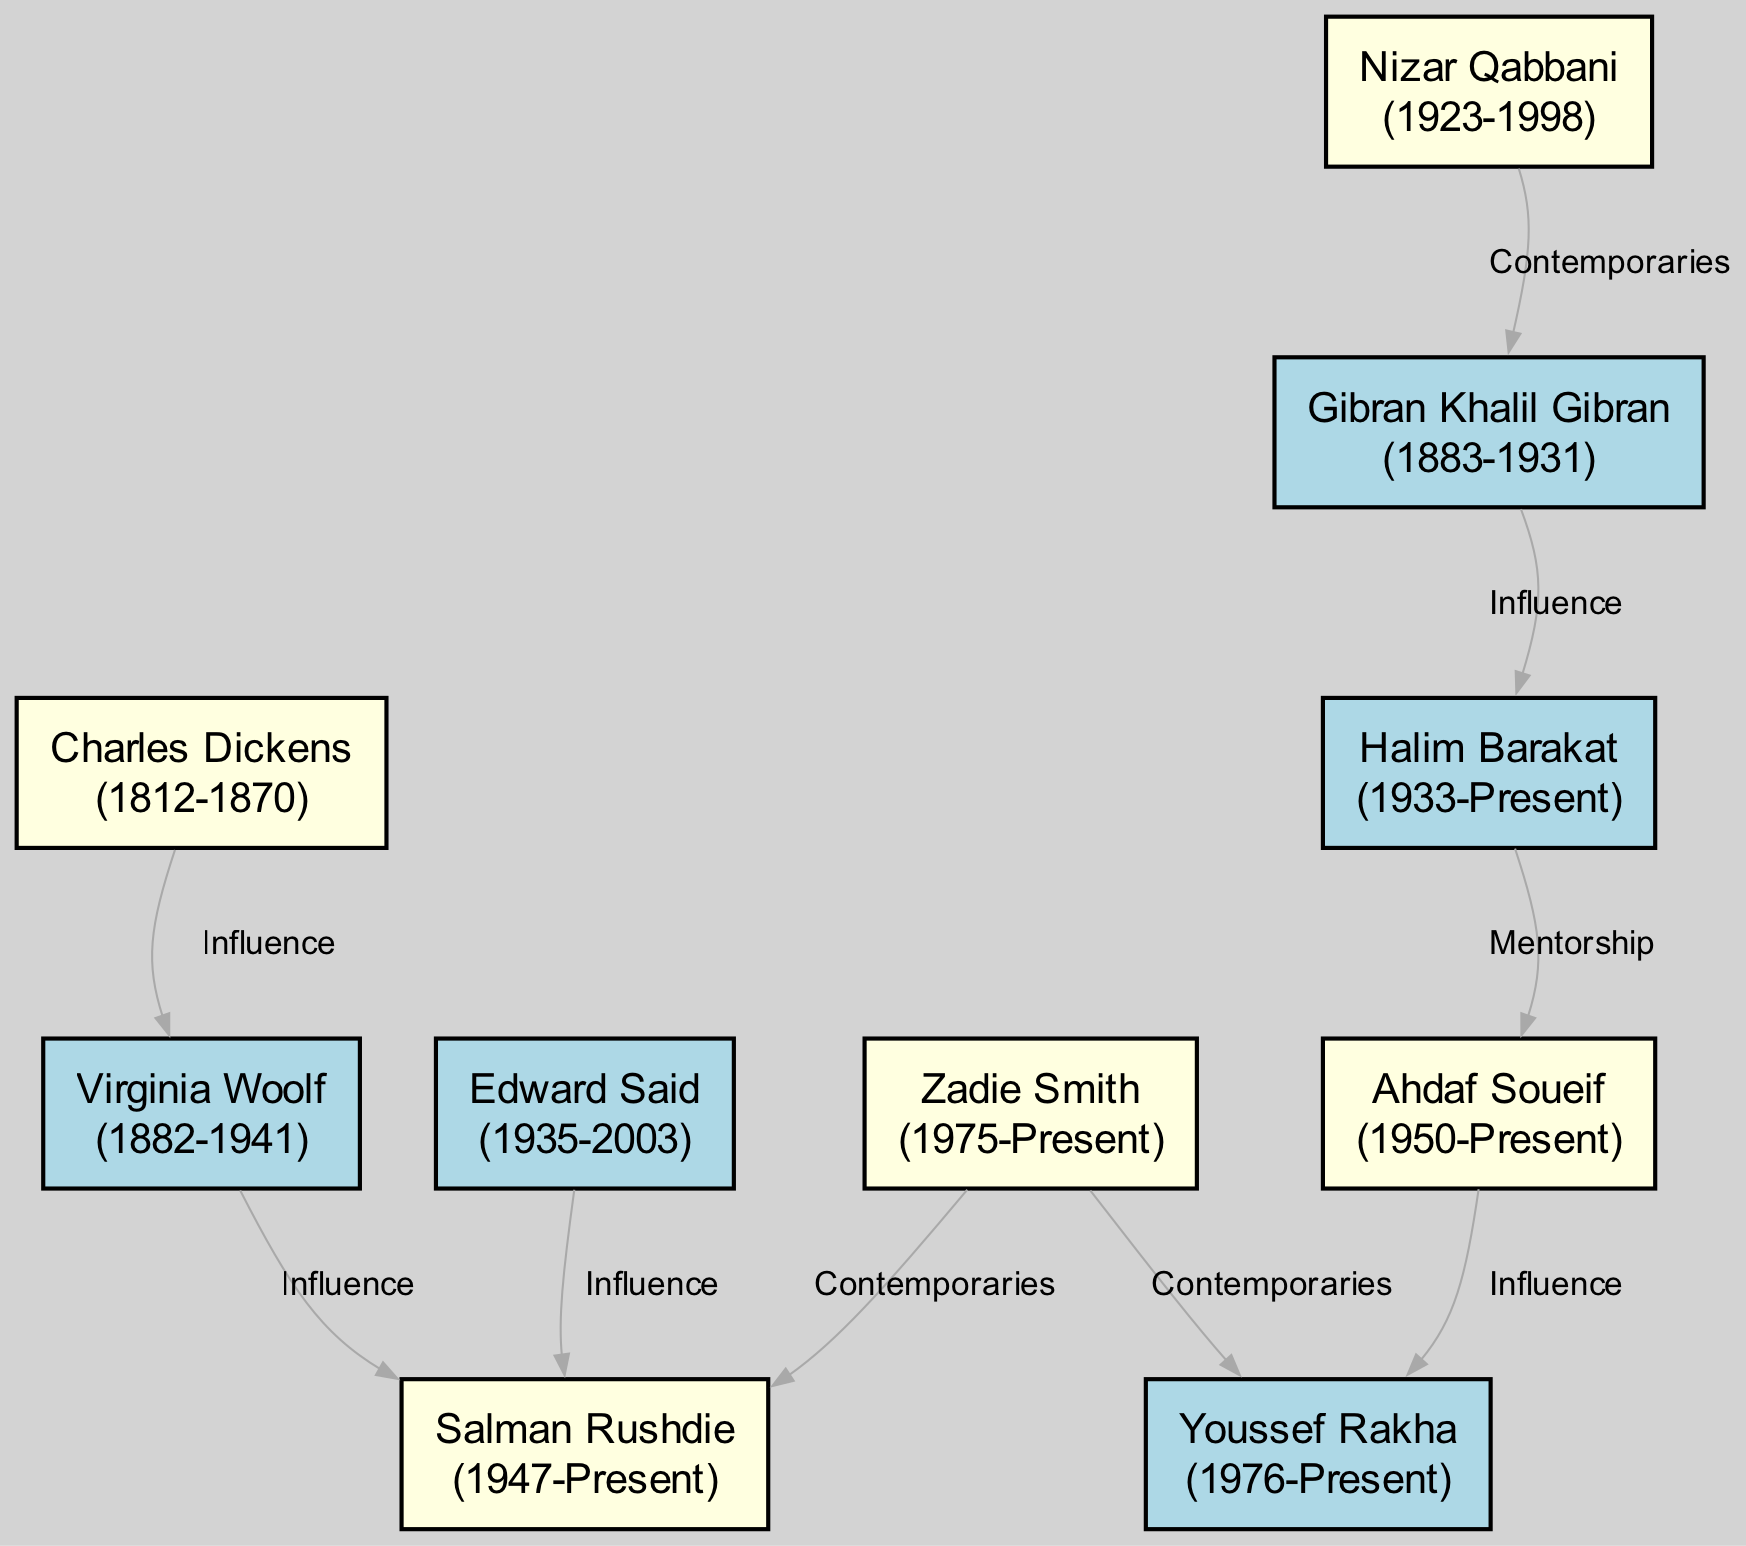How many nodes are in the diagram? The diagram contains 10 nodes, each representing an influential author.
Answer: 10 Who influenced Zadie Smith? Zadie Smith is influenced by Salman Rushdie, as indicated by the directed edge in the diagram.
Answer: Salman Rushdie What is the birth year of Gibran Khalil Gibran? Gibran Khalil Gibran's birth year is 1883, as shown in the node's label.
Answer: 1883 Who are the contemporaries of Salman Rushdie? The contemporaries of Salman Rushdie are Zadie Smith and Edward Said, as indicated by the edges connecting them.
Answer: Zadie Smith and Edward Said Which author is influenced by Halim Barakat? Ahdaf Soueif is influenced by Halim Barakat, as shown by the directional edge labeled "Mentorship."
Answer: Ahdaf Soueif Who is the youngest author in the diagram? Zadie Smith, born in 1975, is the youngest author as represented in the nodes with their birth years.
Answer: Zadie Smith How many connections does Virginia Woolf have? Virginia Woolf has one outgoing connection, which indicates influence on Salman Rushdie.
Answer: 1 List all the authors who influenced Youssef Rakha. Youssef Rakha is influenced by Ahdaf Soueif, according to the directed edge that represents their relationship.
Answer: Ahdaf Soueif What type of relationship exists between Nizar Qabbani and Gibran Khalil Gibran? The relationship between Nizar Qabbani and Gibran Khalil Gibran is labeled as "Contemporaries" in the diagram.
Answer: Contemporaries 